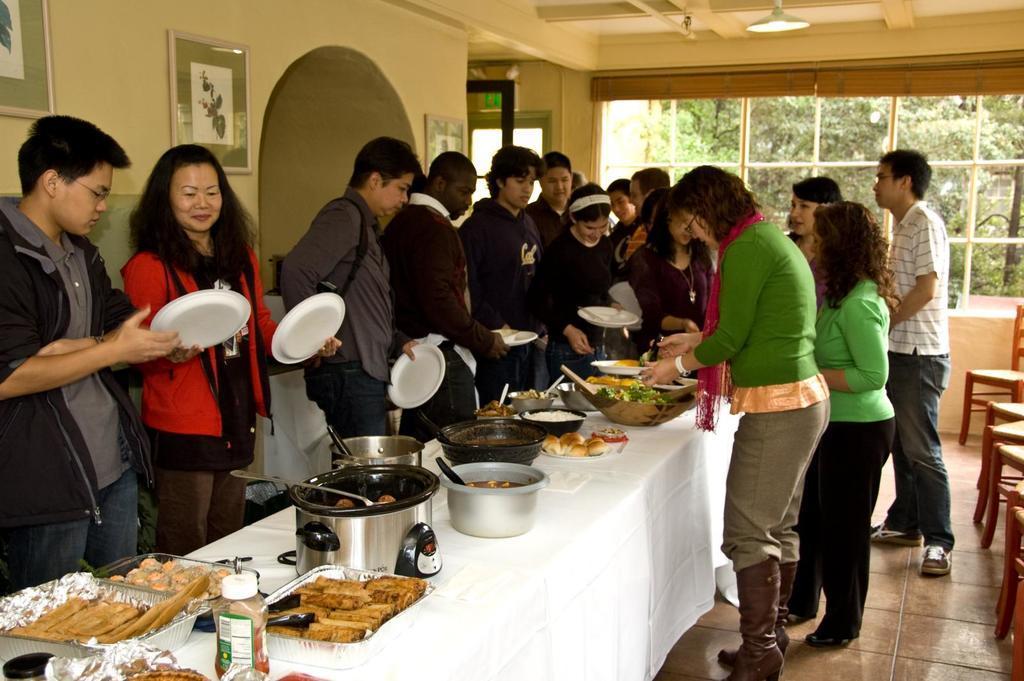How would you summarize this image in a sentence or two? In this picture we can see a group of people standing on the floor, some people are holding plates, in between we can see a table, on this table we can see a cloth, bowls, food items, spoons, bottle, some objects, here we can see chairs and in the background we can see a wall, photo frames, roof, light, window and some objects, from window we can see trees. 